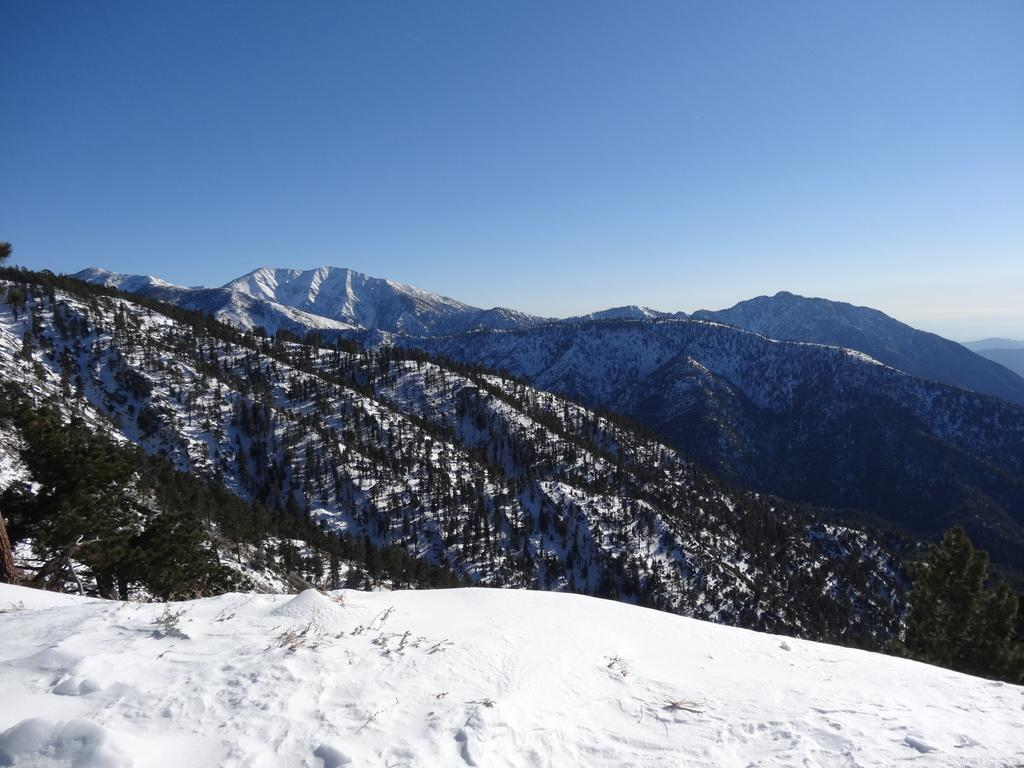What type of weather is depicted in the image? There is snow at the bottom of the image, indicating a winter scene. What can be seen in the middle of the image? There are trees in the middle of the image. What type of landscape is visible in the background of the image? There are mountains at the back side of the image. What is visible at the top of the image? The sky is visible at the top of the image. What type of collar can be seen on the swing in the image? There is no swing or collar present in the image. How does the transport system function in the image? There is no transport system visible in the image. 